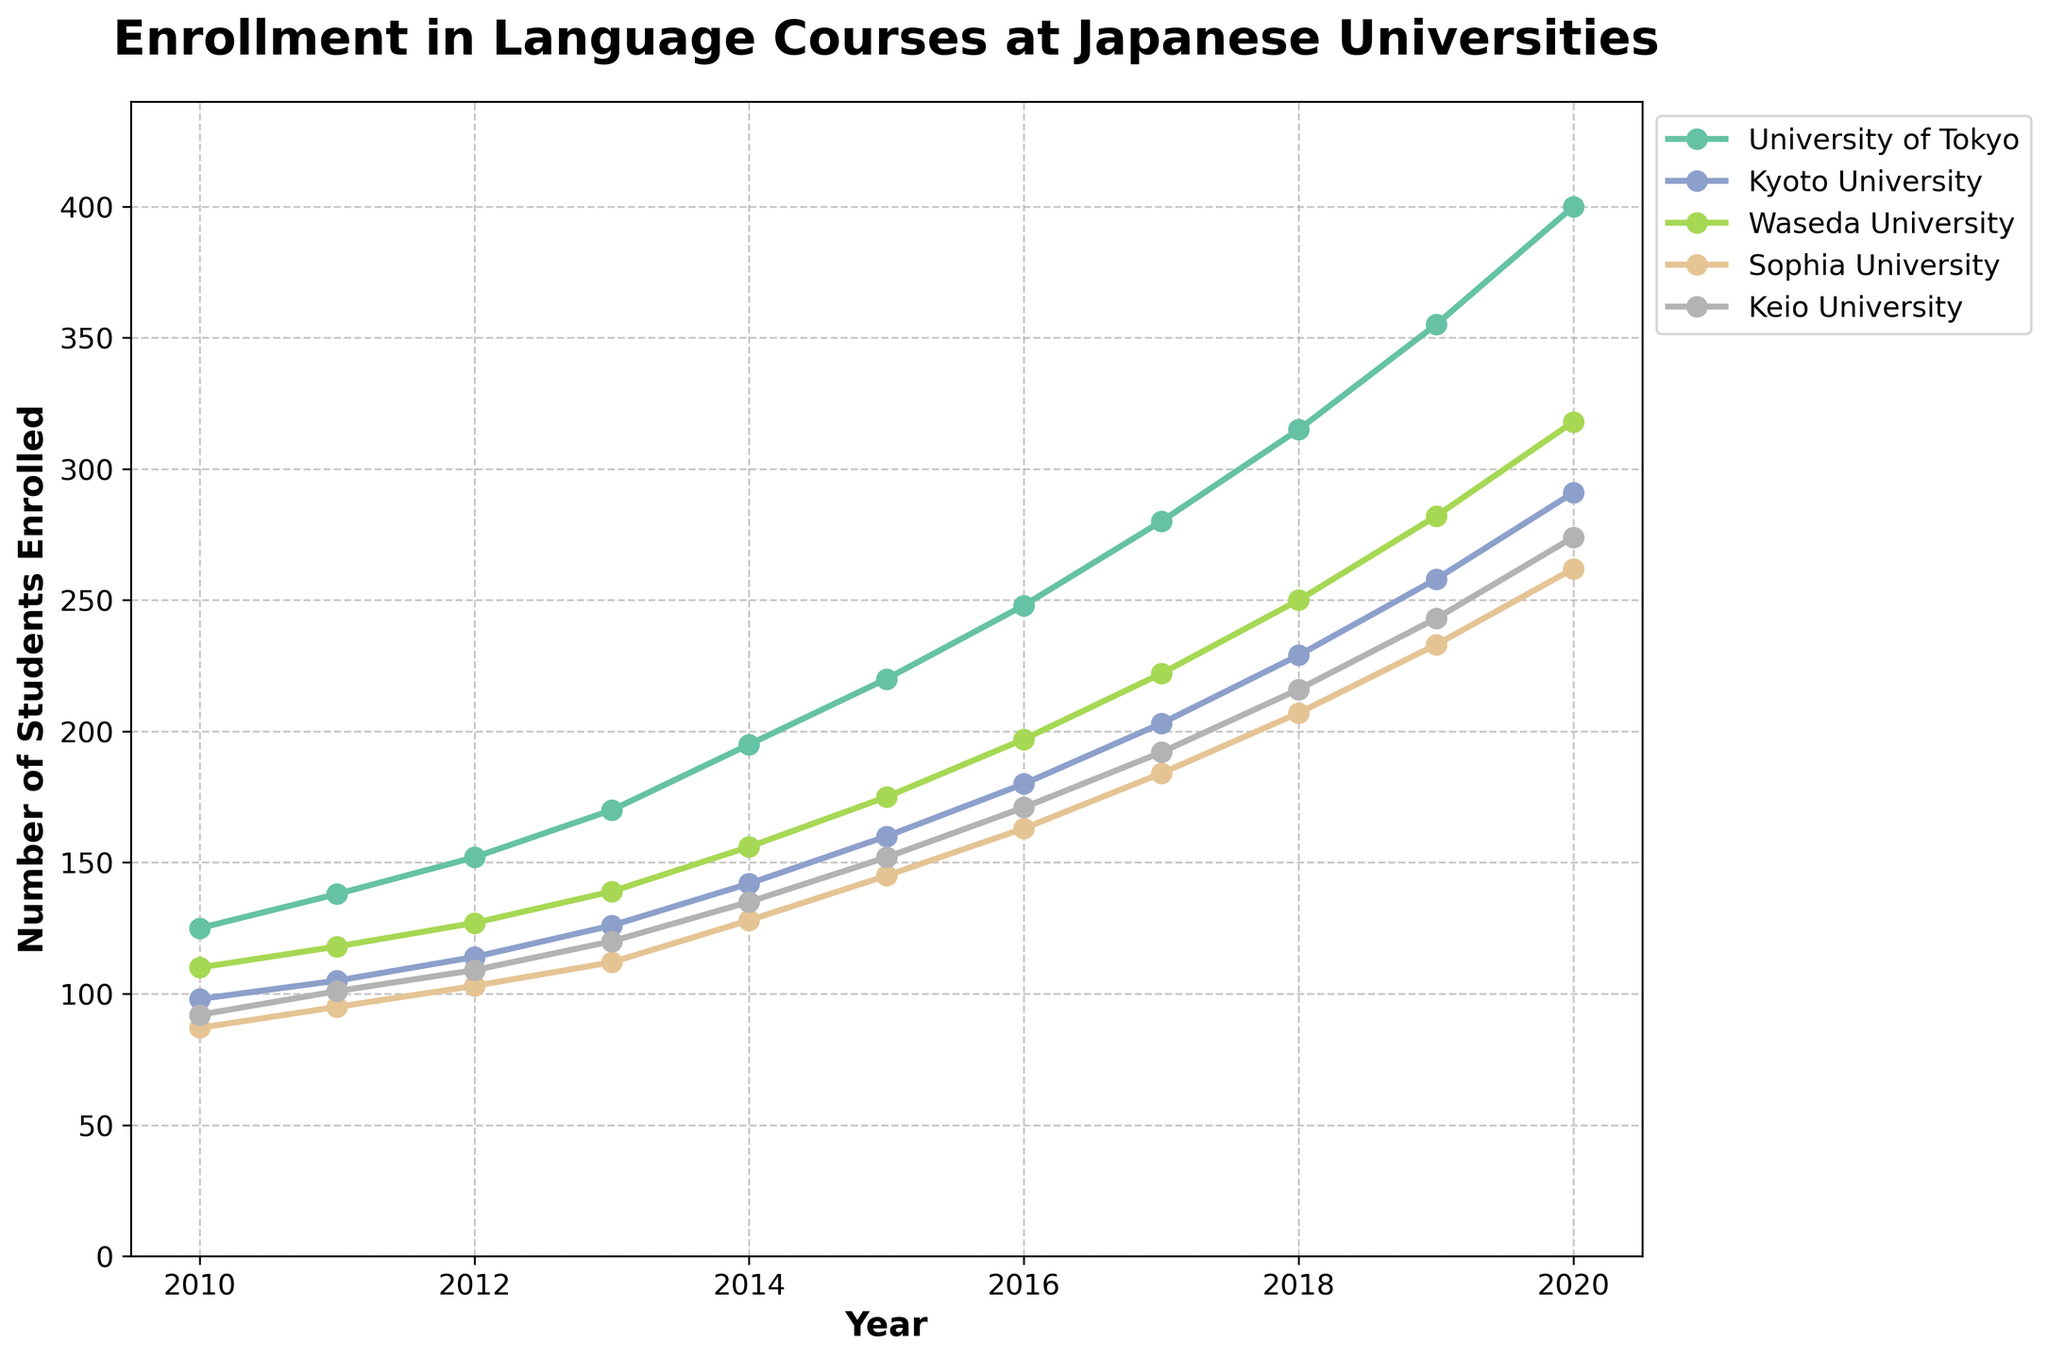Which university had the highest enrollment in 2020? To find the university with the highest enrollment in 2020, look at the end of the plot for the highest point. From the legend, identify which line corresponds to the highest point. The University of Tokyo has the peak enrollments.
Answer: University of Tokyo What was the total enrollment across all universities in 2017? Add the number of students enrolled at each university in 2017: University of Tokyo (280), Kyoto University (203), Waseda University (222), Sophia University (184), and Keio University (192). So, 280 + 203 + 222 + 184 + 192 = 1081.
Answer: 1081 Which university showed the greatest increase in enrollment between 2010 and 2015? Compare the difference in enrollment from 2010 to 2015 for each university. The university with the largest difference is the University of Tokyo: 220 - 125 = 95.
Answer: University of Tokyo How much did the enrollment change for Kyoto University between 2011 and 2014? Subtract the number of students in 2011 from the number in 2014 for Kyoto University: 142 - 105 = 37.
Answer: 37 Between 2016 and 2019, which university had the smallest increase in enrollment? Calculate the change for each university between 2016 and 2019: 
- University of Tokyo: 355 - 248 = 107
- Kyoto University: 258 - 180 = 78
- Waseda University: 282 - 197 = 85
- Sophia University: 233 - 163 = 70
- Keio University: 243 - 171 = 72
Sophia University has the smallest increase, which is 70.
Answer: Sophia University Which year saw the largest overall increase in enrollment across all universities compared to the previous year? Calculate the yearly increases by summing the increases for all universities:
2011: 138+105+118+95+101 - (125+98+110+87+92) = (138-125) + (105-98) + (118-110) + (95-87) + (101-92) = 13+7+8+8+9 = 45
2012: 152+114+127+103+109 - (138+105+118+95+101) = (152-138) + (114-105) + (127-118) + (103-95) + (109-101) = 14+9+9+8+8 = 48
2013: 170+126+139+112+120 - (152+114+127+103+109) = (170-152) + (126-114) + (139-127) + (112-103) + (120-109) = 18+12+12+9+11 = 62
2014: 195+142+156+128+135 - (170+126+139+112+120) = (195-170) + (142-126) + (156-139) + (128-112) + (135-120) = 25+16+17+16+15 = 89
2015: 220+160+175+145+152 - (195+142+156+128+135) = (220-195) + (160-142) + (175-156) + (145-128) + (152-135) = 25+18+19+17+17 = 96
2016: 248+180+197+163+171 - (220+160+175+145+152) = (248-220) + (180-160) + (197-175) + (163-145) + (171-152) = 28+20+22+18+19 = 107
2017: 280+203+222+184+192 - (248+180+197+163+171) = (280-248) + (203-180) + (222-197) + (184-163) + (192-171) = 32+23+25+21+21 = 122
2018: 315+229+250+207+216 - (280+203+222+184+192) = (315-280) + (229-203) + (250-222) + (207-184) + (216-192) = 35+26+28+23+24 = 136
2019: 355+258+282+233+243 - (315+229+250+207+216) = (355-315) + (258-229) + (282-250) + (233-207) + (243-216) = 40+29+32+26+27 = 154
2020: 400+291+318+262+274 - (355+258+282+233+243) = (400-355) + (291-258) + (318-282) + (262-233) + (274-243) = 45+33+36+29+31 = 174
The year 2020 saw the largest increase, which is 174.
Answer: 2020 Which university experienced the least growth in total enrollment from 2010 to 2020? Subtract the enrollment numbers from 2020 and 2010 for each university and find the smallest difference:
- University of Tokyo: 400 - 125 = 275
- Kyoto University: 291 - 98 = 193
- Waseda University: 318 - 110 = 208
- Sophia University: 262 - 87 = 175
- Keio University: 274 - 92 = 182
Sophia University experienced the least growth, which is 175.
Answer: Sophia University 